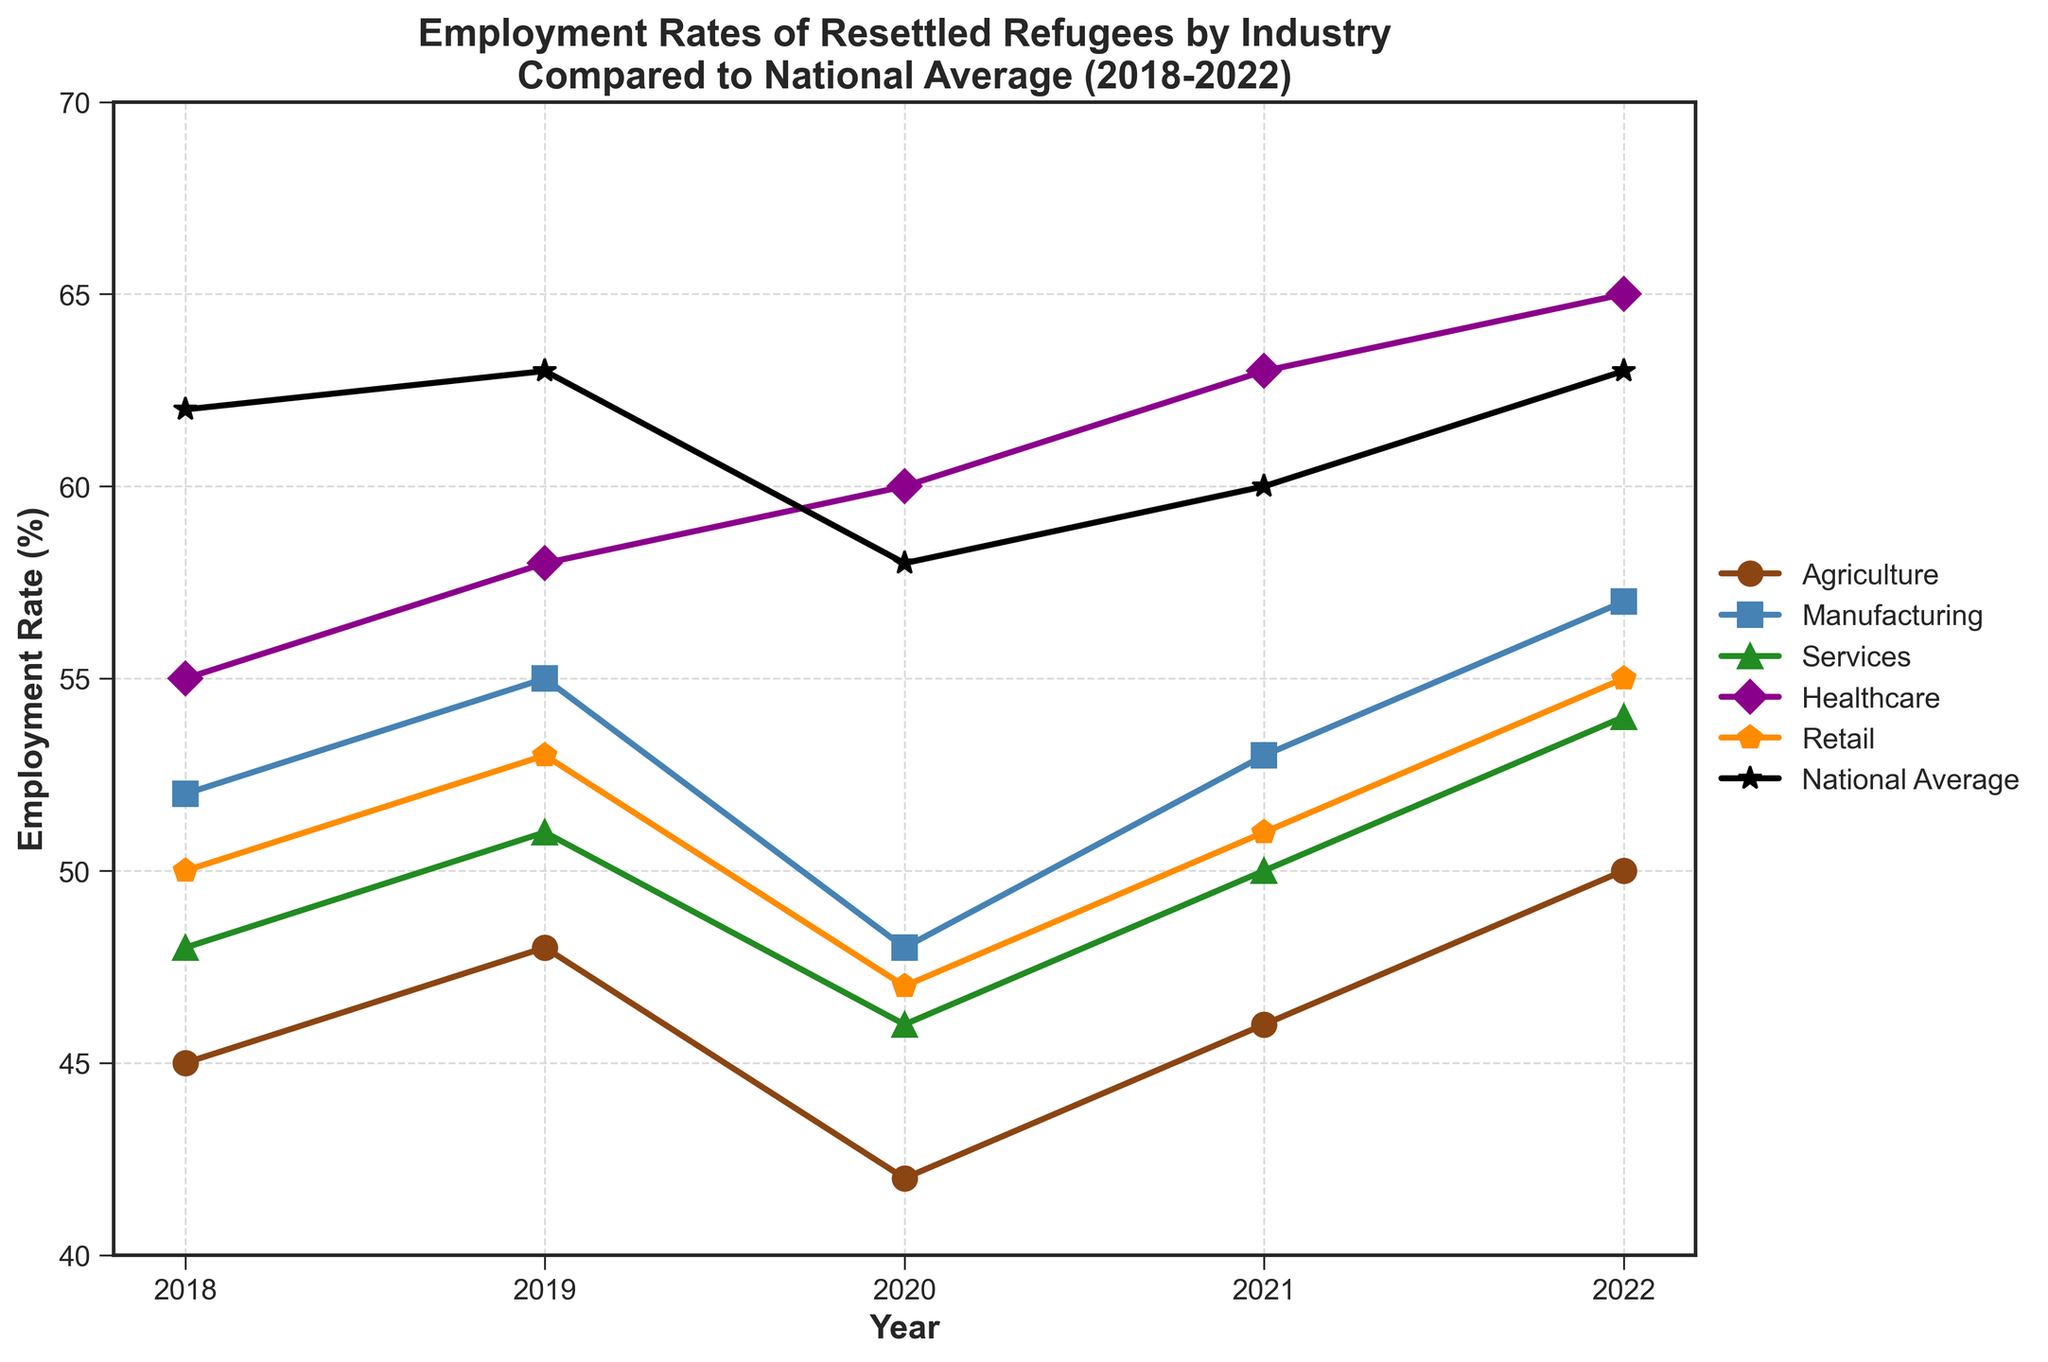What was the employment rate in Healthcare in 2020? Looking at the plot, find the data point that represents the year 2020 under the Healthcare label.
Answer: 60 Which industry showed the highest employment rate in 2018? Find the highest data point on the plot for the year 2018 and identify its associated industry by its color and marker style.
Answer: Healthcare How did the employment rate in Agriculture change from 2019 to 2020? Compare the data points for Agriculture in 2019 and 2020; subtract the 2020 value from the 2019 value to find the change.
Answer: Decreased by 6 Which industry had a consistently increasing employment rate from 2018 to 2022? Follow the line plots for each industry from 2018 to 2022 and identify which one shows a continuous upward trend.
Answer: Healthcare What is the difference between the highest and lowest employment rates across all industries in 2022? Identify the highest value and lowest value data points for the year 2022 across all industries, then subtract the lowest from the highest.
Answer: 25 How does the employment rate of resettled refugees in Manufacturing in 2021 compare to the national average in the same year? Find the data point for Manufacturing and the national average in 2021, then compare their values to see which is higher.
Answer: Lower Which year had the highest national average employment rate? Examine the plot and find the highest data point for the National Average line, then note the corresponding year.
Answer: 2019 From 2018 to 2022, which industry had the least volatility in employment rates? Examine the fluctuations in the line plots for each industry over the given years and identify the one with the smallest changes in values.
Answer: Healthcare What is the average employment rate in the Retail industry over the 5-year period? Sum the employment rates for Retail from 2018 to 2022, then divide by 5 to find the average. (50+53+47+51+55)/5 = 255/5 = 51
Answer: 51 How does the 2020 employment rate in Services compare to the 2022 rate in the same industry? Observe the plot points for Services in 2020 and 2022, then compare their values to identify any increase or decrease.
Answer: Increased by 8 